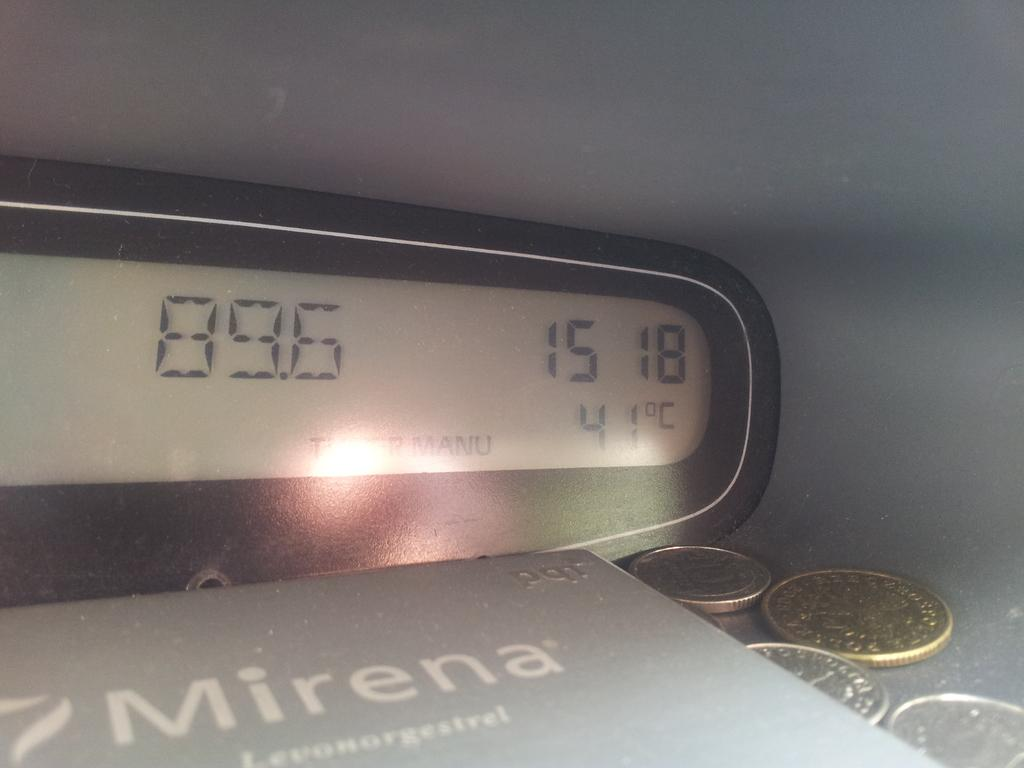<image>
Create a compact narrative representing the image presented. A Book titled Mirena with a digital watch and some coins on the table 